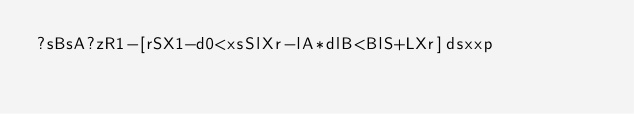<code> <loc_0><loc_0><loc_500><loc_500><_dc_>?sBsA?zR1-[rSX1-d0<xsSlXr-lA*dlB<BlS+LXr]dsxxp</code> 